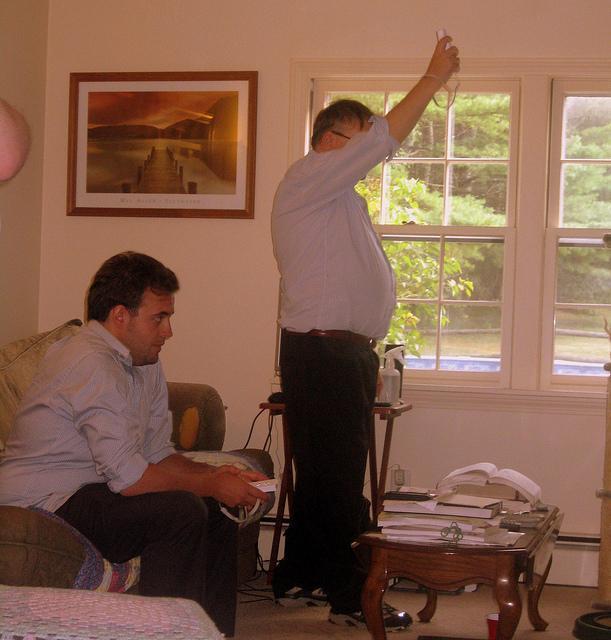How many picture frames are seen on the wall?
Give a very brief answer. 1. How many people are seated?
Give a very brief answer. 1. How many people can you see?
Give a very brief answer. 2. How many couches can be seen?
Give a very brief answer. 1. 